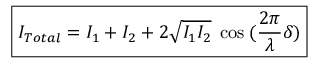<formula> <loc_0><loc_0><loc_500><loc_500>\boxed { I _ { T o t a l } = I _ { 1 } + I _ { 2 } + 2 \sqrt { I _ { 1 } I _ { 2 } } \, \cos \, ( \frac { 2 \pi } { \lambda } \delta ) }</formula> 